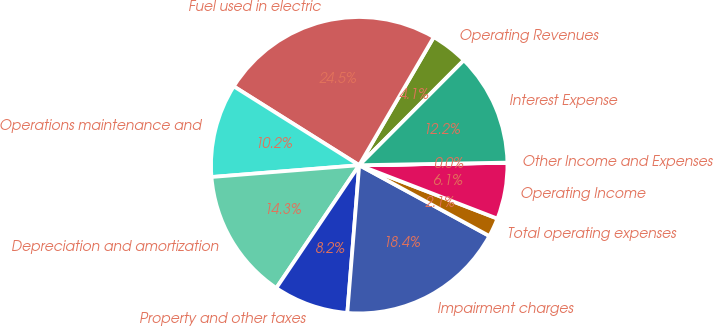<chart> <loc_0><loc_0><loc_500><loc_500><pie_chart><fcel>Operating Revenues<fcel>Fuel used in electric<fcel>Operations maintenance and<fcel>Depreciation and amortization<fcel>Property and other taxes<fcel>Impairment charges<fcel>Total operating expenses<fcel>Operating Income<fcel>Other Income and Expenses<fcel>Interest Expense<nl><fcel>4.09%<fcel>24.46%<fcel>10.2%<fcel>14.28%<fcel>8.17%<fcel>18.35%<fcel>2.06%<fcel>6.13%<fcel>0.02%<fcel>12.24%<nl></chart> 